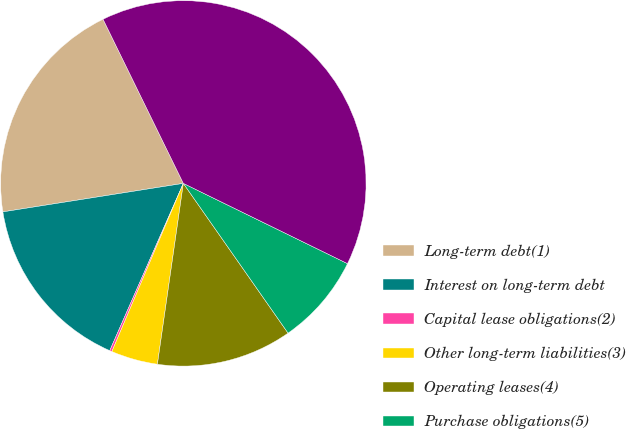<chart> <loc_0><loc_0><loc_500><loc_500><pie_chart><fcel>Long-term debt(1)<fcel>Interest on long-term debt<fcel>Capital lease obligations(2)<fcel>Other long-term liabilities(3)<fcel>Operating leases(4)<fcel>Purchase obligations(5)<fcel>Total financial obligations<nl><fcel>20.25%<fcel>15.91%<fcel>0.2%<fcel>4.13%<fcel>11.98%<fcel>8.05%<fcel>39.48%<nl></chart> 